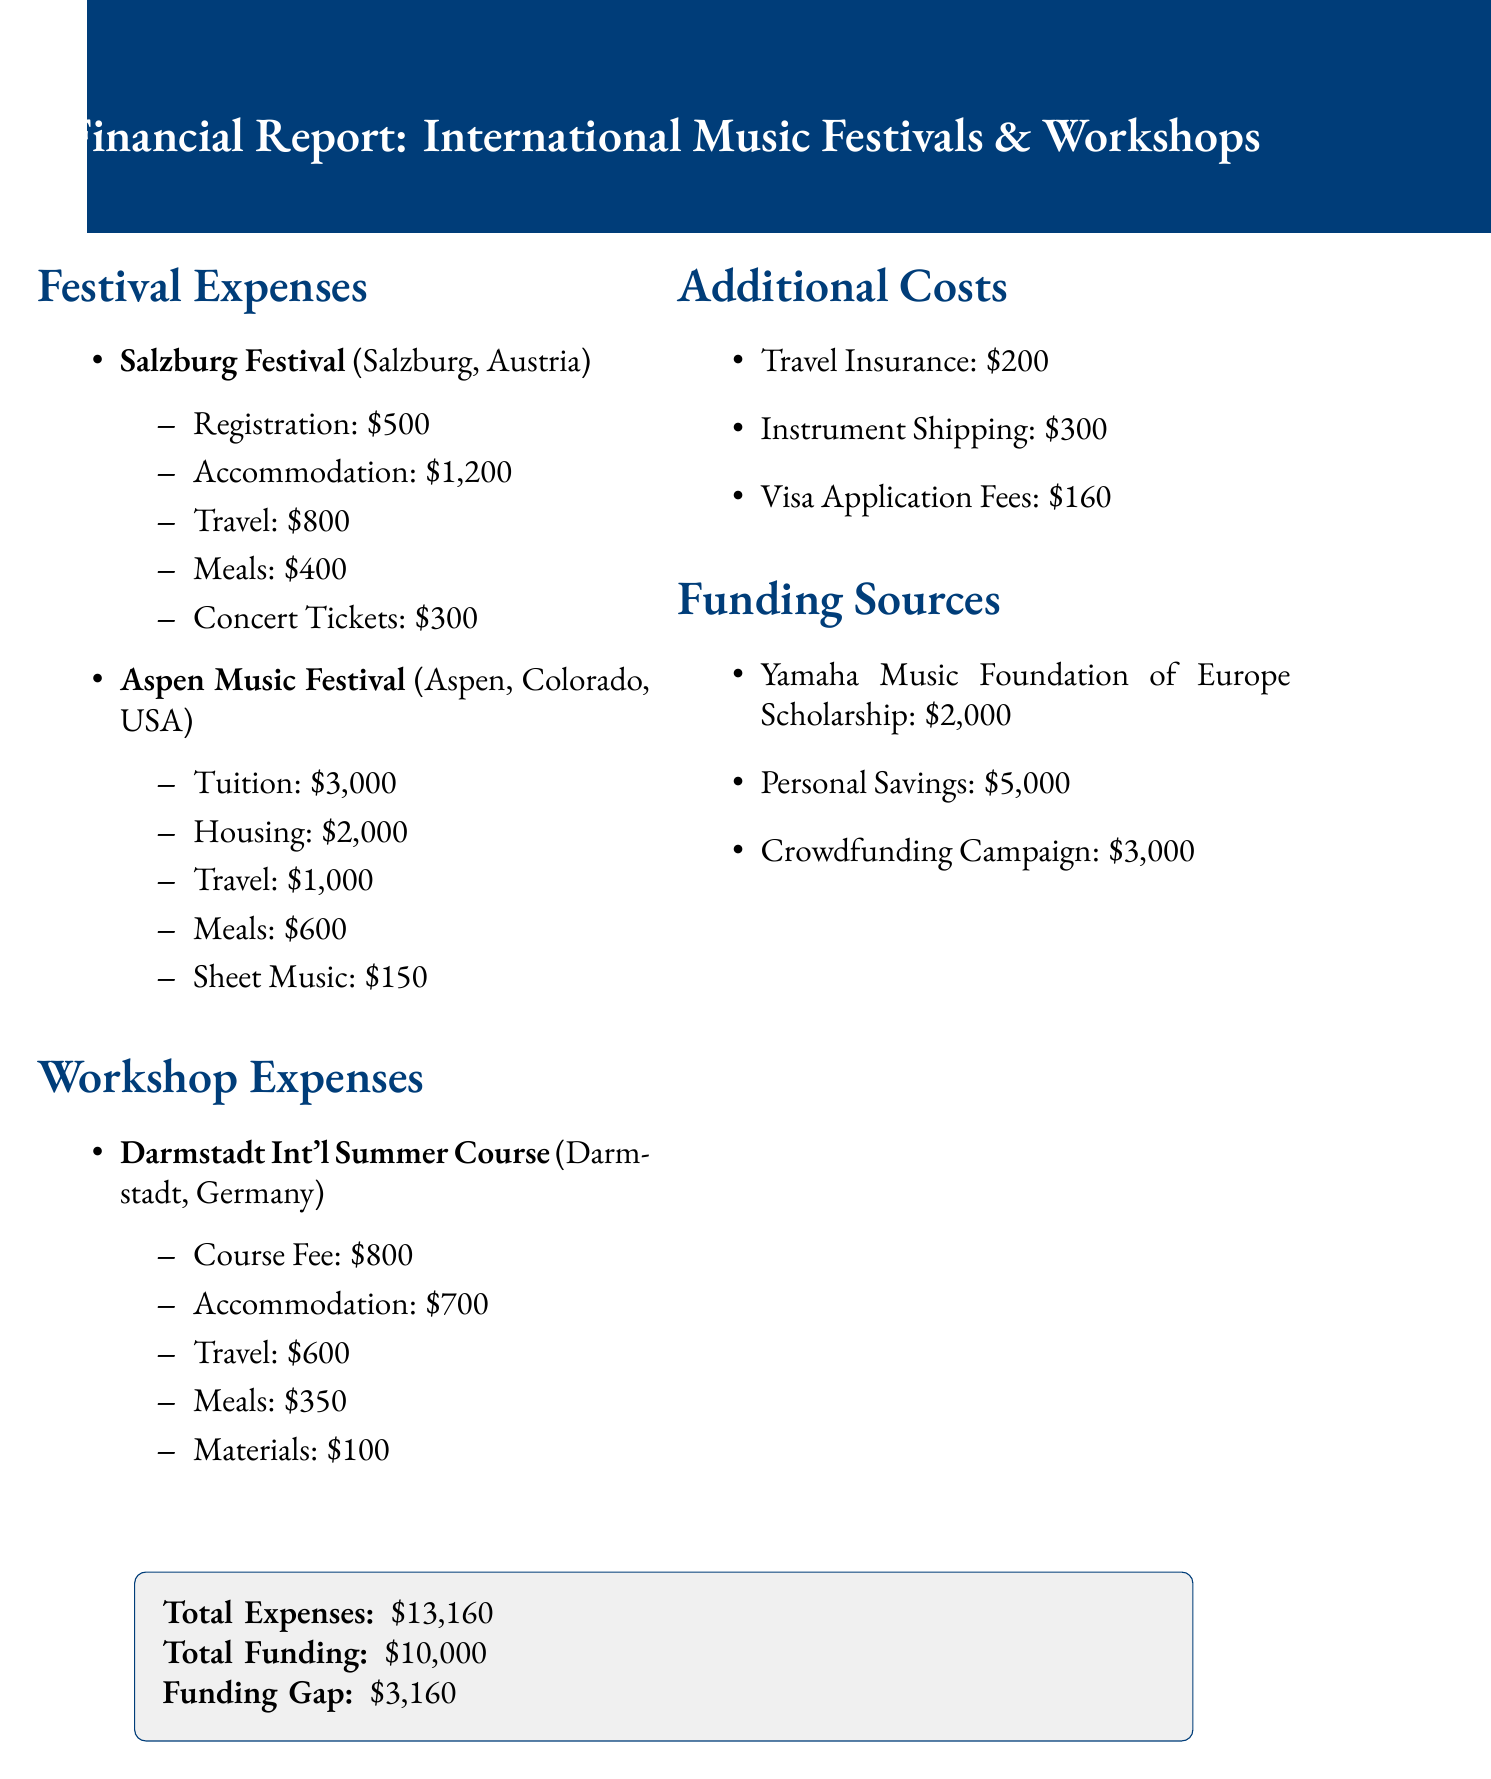What is the total amount of festival expenses? The total festival expenses are the sum of all individual festival expenses, which is $500 + $1200 + $800 + $400 + $300 + $3000 + $2000 + $1000 + $600 + $150 = $10,000.
Answer: $10,000 What is the location of the Aspen Music Festival? The document specifies that the Aspen Music Festival is located in Aspen, Colorado, USA.
Answer: Aspen, Colorado, USA What is the course fee for the Darmstadt International Summer Course for New Music? The document lists the course fee as $800 for the Darmstadt International Summer Course for New Music.
Answer: $800 What are the total additional costs? The total additional costs are the sum of all listed items which are $200 + $300 + $160 = $660.
Answer: $660 How much funding does the Yamaha Music Foundation of Europe Scholarship provide? According to the document, the Yamaha Music Foundation of Europe Scholarship provides $2,000.
Answer: $2,000 What is the total funding compared to total expenses? The document states that total funding is $10,000 and total expenses are $13,160, indicating a funding gap.
Answer: $13,160 Which festival has the highest registration fee? The Salzburg Festival has the highest registration fee, which is $500.
Answer: Salzburg Festival What is the total funding gap? The funding gap is calculated by subtracting total funding from total expenses, which is $13,160 - $10,000 = $3,160.
Answer: $3,160 What is included in the additional costs? The additional costs section includes travel insurance, instrument shipping, and visa application fees.
Answer: Travel insurance, instrument shipping, visa application fees 